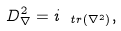<formula> <loc_0><loc_0><loc_500><loc_500>D _ { \nabla } ^ { 2 } = i _ { \ t r ( \nabla ^ { 2 } ) } ,</formula> 